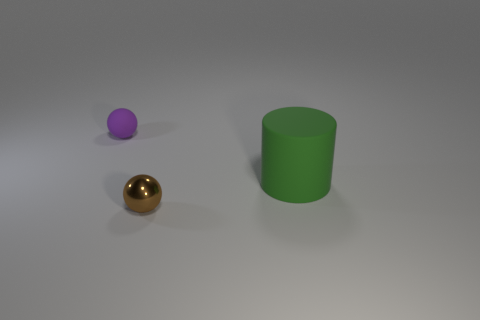Add 3 tiny matte things. How many objects exist? 6 Subtract all spheres. How many objects are left? 1 Add 2 tiny purple matte objects. How many tiny purple matte objects are left? 3 Add 2 small rubber cylinders. How many small rubber cylinders exist? 2 Subtract 0 red blocks. How many objects are left? 3 Subtract all big blue cubes. Subtract all matte things. How many objects are left? 1 